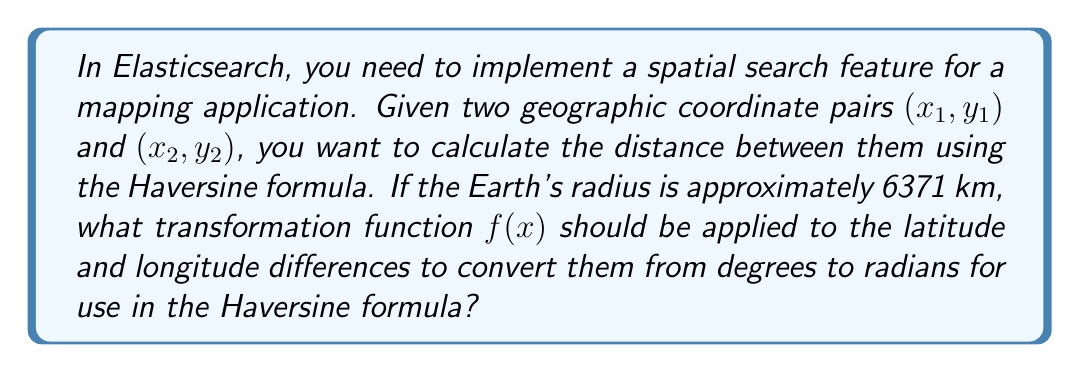Could you help me with this problem? To solve this problem, we need to follow these steps:

1. Recall that the Haversine formula requires angles in radians, but geographic coordinates are typically given in degrees.

2. The conversion from degrees to radians is given by the formula:
   $$\text{radians} = \frac{\text{degrees} \times \pi}{180}$$

3. Therefore, we need to define a transformation function $f(x)$ that takes an angle in degrees and returns it in radians:
   $$f(x) = \frac{x \times \pi}{180}$$

4. This transformation function should be applied to the differences in latitude and longitude before using them in the Haversine formula.

5. In Elasticsearch, you would typically use this transformation within a script or as part of a custom scoring function when implementing spatial search queries.
Answer: $f(x) = \frac{x \times \pi}{180}$ 